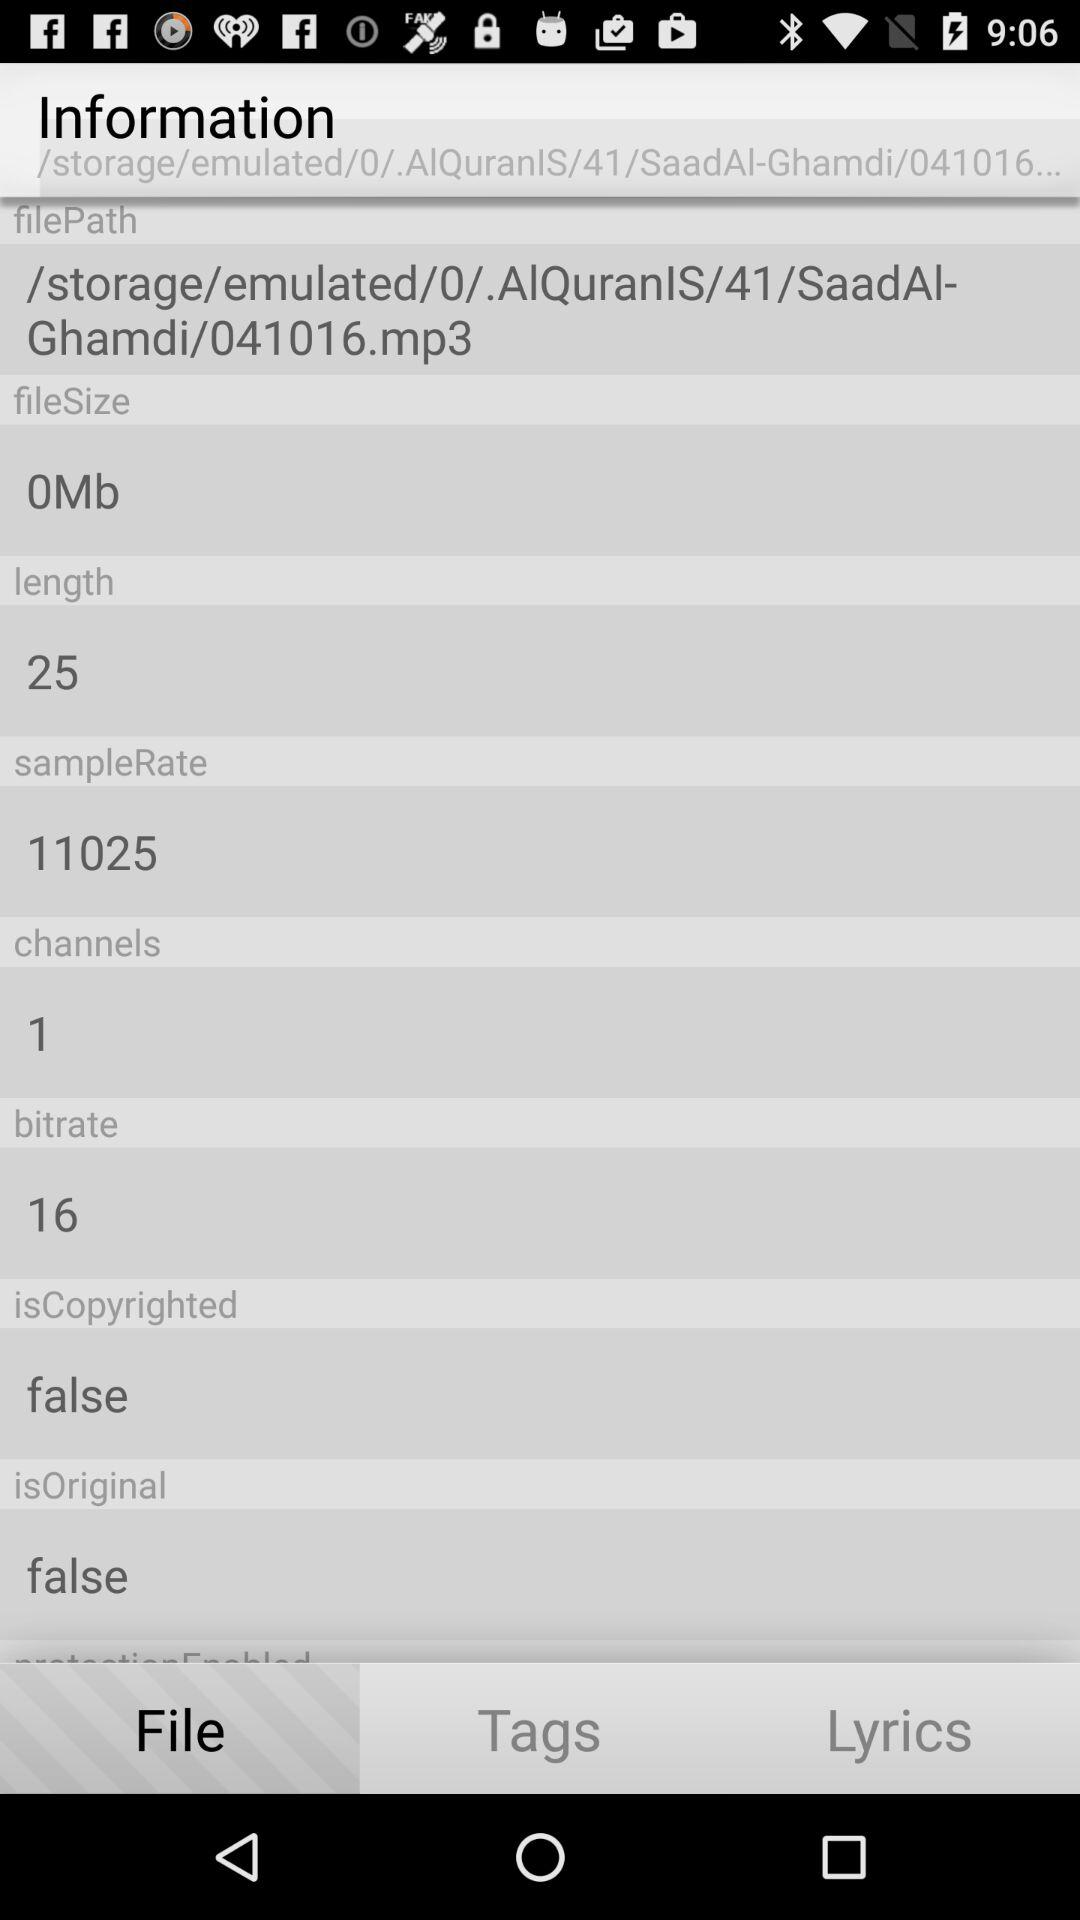What is the bitrate? The bitrate is 16. 